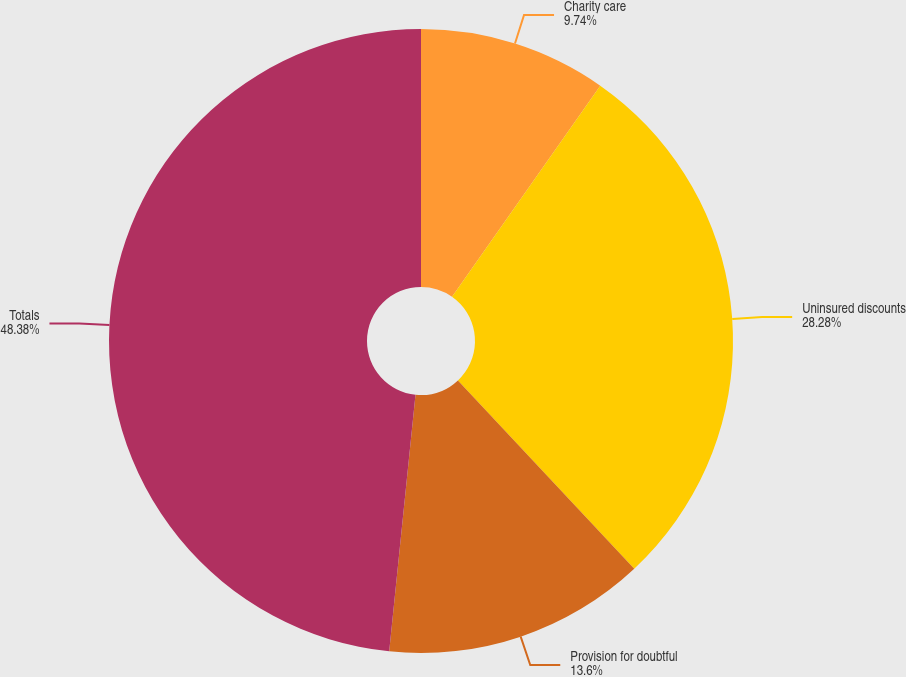<chart> <loc_0><loc_0><loc_500><loc_500><pie_chart><fcel>Charity care<fcel>Uninsured discounts<fcel>Provision for doubtful<fcel>Totals<nl><fcel>9.74%<fcel>28.28%<fcel>13.6%<fcel>48.37%<nl></chart> 